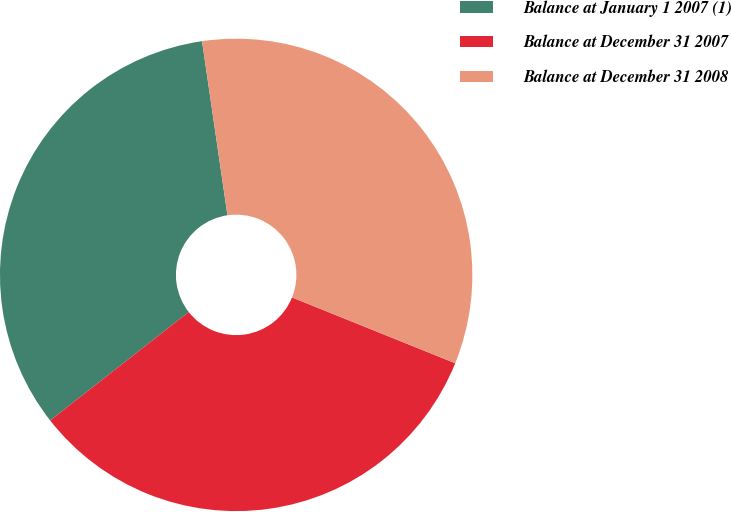<chart> <loc_0><loc_0><loc_500><loc_500><pie_chart><fcel>Balance at January 1 2007 (1)<fcel>Balance at December 31 2007<fcel>Balance at December 31 2008<nl><fcel>33.26%<fcel>33.33%<fcel>33.41%<nl></chart> 